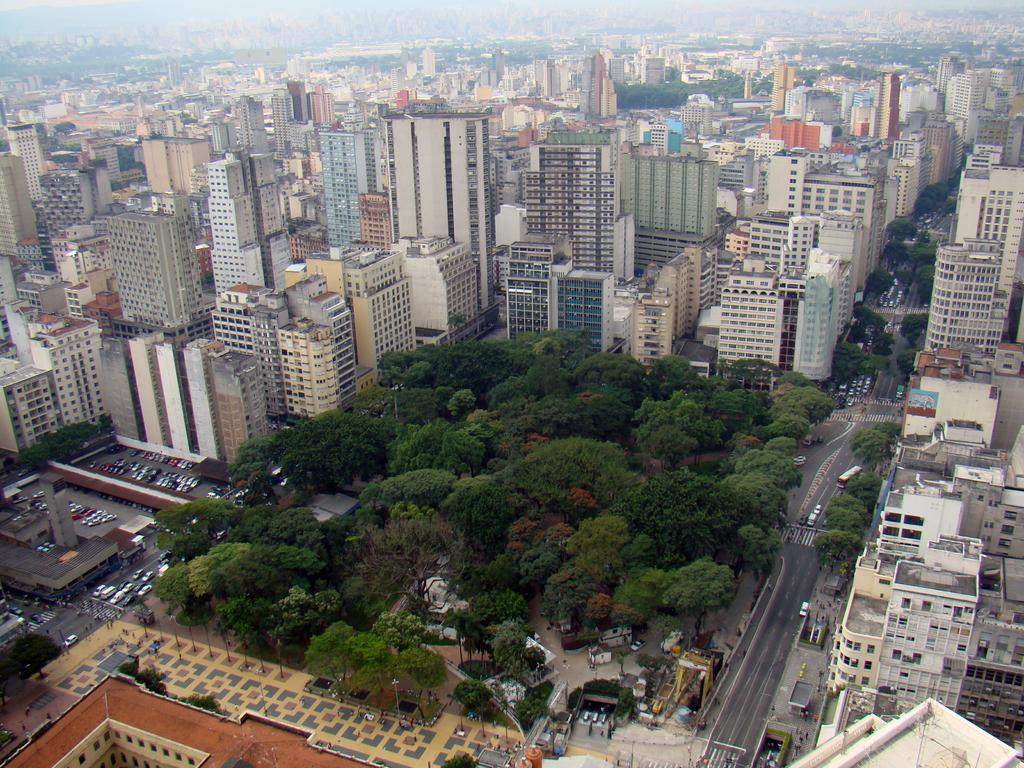What type of view is shown in the image? The image is an aerial view of a city. What structures can be seen in the image? There are buildings in the image. What else can be seen moving in the image? There are vehicles in the image. What type of natural elements are present in the image? There are trees in the image. What type of pathway is visible in the image? There is a road visible in the image. What type of soap is being used to clean the stone in the image? There is no soap or stone present in the image; it is an aerial view of a city with buildings, vehicles, trees, and a road. 